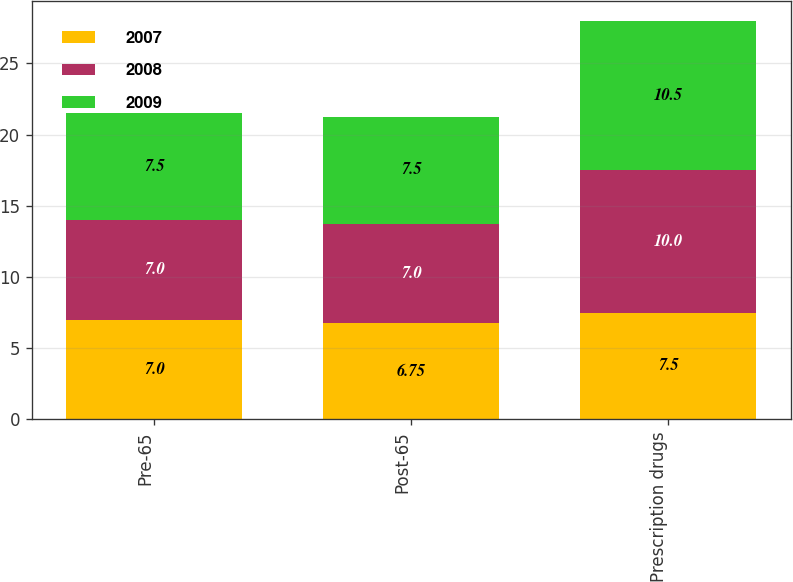Convert chart to OTSL. <chart><loc_0><loc_0><loc_500><loc_500><stacked_bar_chart><ecel><fcel>Pre-65<fcel>Post-65<fcel>Prescription drugs<nl><fcel>2007<fcel>7<fcel>6.75<fcel>7.5<nl><fcel>2008<fcel>7<fcel>7<fcel>10<nl><fcel>2009<fcel>7.5<fcel>7.5<fcel>10.5<nl></chart> 